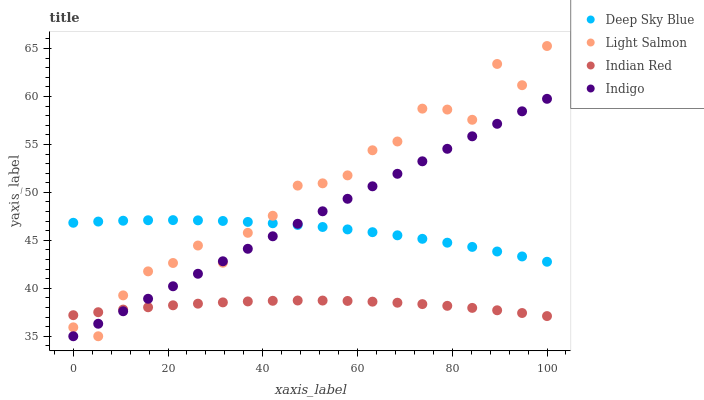Does Indian Red have the minimum area under the curve?
Answer yes or no. Yes. Does Light Salmon have the maximum area under the curve?
Answer yes or no. Yes. Does Indigo have the minimum area under the curve?
Answer yes or no. No. Does Indigo have the maximum area under the curve?
Answer yes or no. No. Is Indigo the smoothest?
Answer yes or no. Yes. Is Light Salmon the roughest?
Answer yes or no. Yes. Is Indian Red the smoothest?
Answer yes or no. No. Is Indian Red the roughest?
Answer yes or no. No. Does Light Salmon have the lowest value?
Answer yes or no. Yes. Does Indian Red have the lowest value?
Answer yes or no. No. Does Light Salmon have the highest value?
Answer yes or no. Yes. Does Indigo have the highest value?
Answer yes or no. No. Is Indian Red less than Deep Sky Blue?
Answer yes or no. Yes. Is Deep Sky Blue greater than Indian Red?
Answer yes or no. Yes. Does Deep Sky Blue intersect Light Salmon?
Answer yes or no. Yes. Is Deep Sky Blue less than Light Salmon?
Answer yes or no. No. Is Deep Sky Blue greater than Light Salmon?
Answer yes or no. No. Does Indian Red intersect Deep Sky Blue?
Answer yes or no. No. 